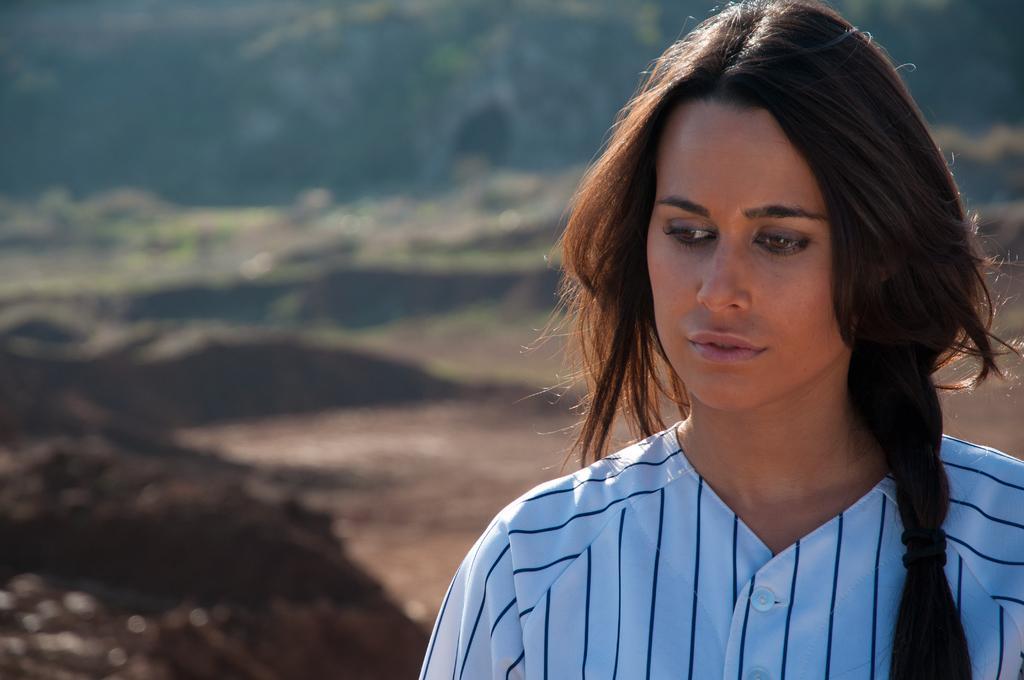Describe this image in one or two sentences. The girl on the right corner of the picture wearing a white shirt is standing. Beside her, we see black soil. Behind her, there are trees and it is blurred in the background. 